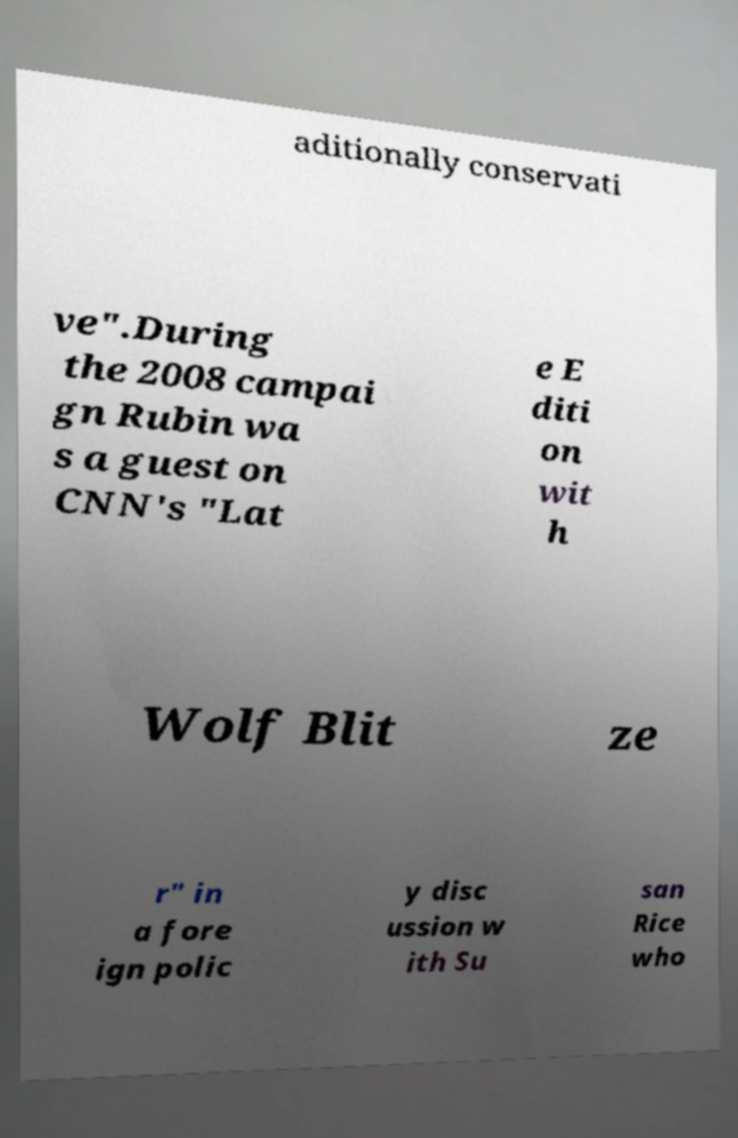Can you accurately transcribe the text from the provided image for me? aditionally conservati ve".During the 2008 campai gn Rubin wa s a guest on CNN's "Lat e E diti on wit h Wolf Blit ze r" in a fore ign polic y disc ussion w ith Su san Rice who 